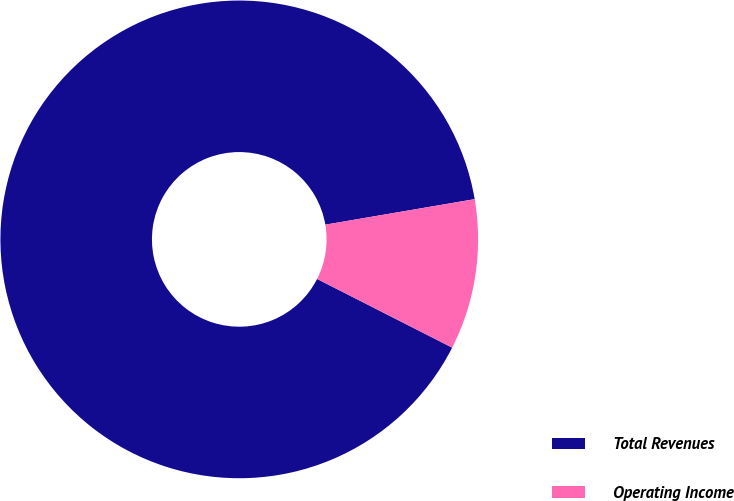Convert chart. <chart><loc_0><loc_0><loc_500><loc_500><pie_chart><fcel>Total Revenues<fcel>Operating Income<nl><fcel>89.82%<fcel>10.18%<nl></chart> 